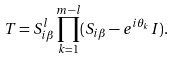<formula> <loc_0><loc_0><loc_500><loc_500>T = S _ { i \beta } ^ { l } \prod _ { k = 1 } ^ { m - l } ( S _ { i \beta } - e ^ { i \theta _ { k } } I ) .</formula> 